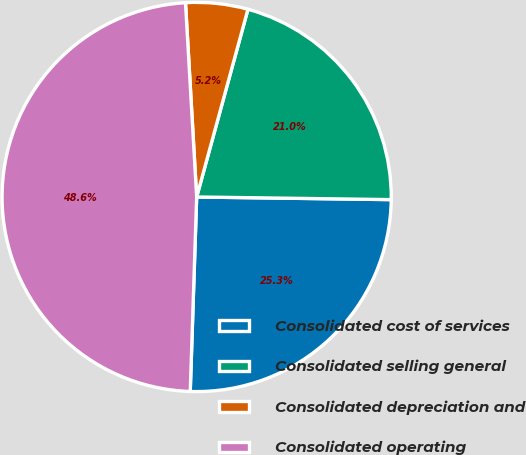Convert chart to OTSL. <chart><loc_0><loc_0><loc_500><loc_500><pie_chart><fcel>Consolidated cost of services<fcel>Consolidated selling general<fcel>Consolidated depreciation and<fcel>Consolidated operating<nl><fcel>25.31%<fcel>20.97%<fcel>5.16%<fcel>48.56%<nl></chart> 